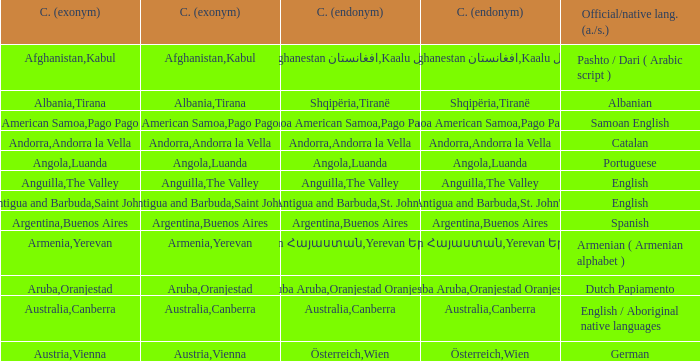What is the local name given to the capital of Anguilla? The Valley. 